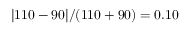<formula> <loc_0><loc_0><loc_500><loc_500>| 1 1 0 - 9 0 | / ( 1 1 0 + 9 0 ) = 0 . 1 0</formula> 